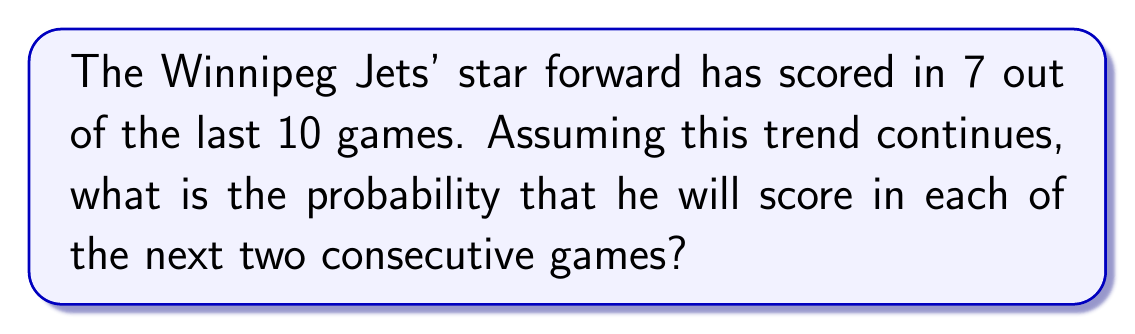Can you solve this math problem? To solve this problem, we need to use the concept of independent events and multiplication rule of probability.

1) First, let's define the probability of the player scoring in a single game:
   $P(\text{scoring in one game}) = \frac{7}{10} = 0.7$

2) We want to find the probability of scoring in two consecutive games. These are independent events, so we multiply the individual probabilities:

   $P(\text{scoring in two consecutive games}) = P(\text{scoring in first game}) \times P(\text{scoring in second game})$

3) Substituting the probability we found in step 1:

   $P(\text{scoring in two consecutive games}) = 0.7 \times 0.7 = 0.49$

4) We can express this as a fraction:

   $0.49 = \frac{49}{100}$

Therefore, the probability of the player scoring in each of the next two consecutive games is $\frac{49}{100}$ or 0.49 or 49%.
Answer: $\frac{49}{100}$ or 0.49 or 49% 